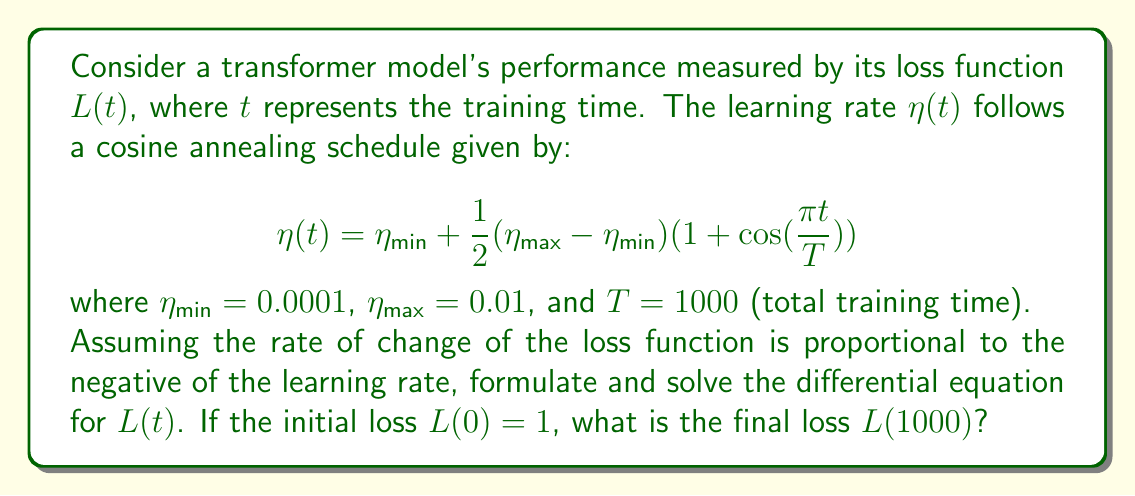Solve this math problem. Let's approach this step-by-step:

1) First, we formulate the differential equation. Given that the rate of change of the loss function is proportional to the negative of the learning rate, we can write:

   $$\frac{dL}{dt} = -k\eta(t)$$

   where $k$ is a positive constant representing the proportionality.

2) Substituting the given learning rate schedule:

   $$\frac{dL}{dt} = -k(\eta_{min} + \frac{1}{2}(\eta_{max} - \eta_{min})(1 + \cos(\frac{\pi t}{T})))$$

3) To solve this, we need to integrate both sides:

   $$\int dL = -k\int (\eta_{min} + \frac{1}{2}(\eta_{max} - \eta_{min})(1 + \cos(\frac{\pi t}{T}))) dt$$

4) Let's break this into parts:
   
   $$L = -k\eta_{min}t - k\frac{1}{2}(\eta_{max} - \eta_{min})t - k\frac{1}{2}(\eta_{max} - \eta_{min})\frac{T}{\pi}\sin(\frac{\pi t}{T}) + C$$

5) Now, we can use the initial condition $L(0) = 1$ to find $C$:

   $$1 = 0 + 0 + 0 + C$$
   $$C = 1$$

6) So, our full solution is:

   $$L(t) = 1 - k\eta_{min}t - k\frac{1}{2}(\eta_{max} - \eta_{min})t - k\frac{1}{2}(\eta_{max} - \eta_{min})\frac{T}{\pi}\sin(\frac{\pi t}{T})$$

7) To find $L(1000)$, we substitute $t = 1000$, $T = 1000$, $\eta_{min} = 0.0001$, and $\eta_{max} = 0.01$:

   $$L(1000) = 1 - 1000k(0.0001) - 500k(0.01 - 0.0001) - 500k(0.01 - 0.0001)\frac{1000}{\pi}\sin(\pi)$$

8) Simplifying:

   $$L(1000) = 1 - 0.1k - 4.95k - 0 = 1 - 5.05k$$

The final loss depends on the value of $k$, which wasn't specified in the problem. However, we can express the answer in terms of $k$.
Answer: $L(1000) = 1 - 5.05k$, where $k$ is the positive constant of proportionality between the rate of change of the loss function and the negative of the learning rate. 